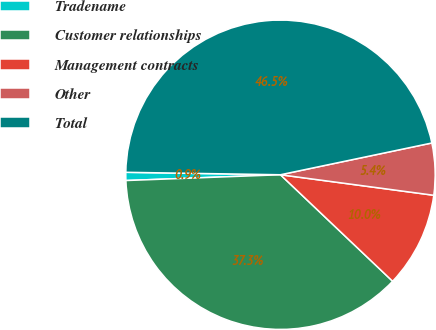Convert chart. <chart><loc_0><loc_0><loc_500><loc_500><pie_chart><fcel>Tradename<fcel>Customer relationships<fcel>Management contracts<fcel>Other<fcel>Total<nl><fcel>0.85%<fcel>37.31%<fcel>9.97%<fcel>5.41%<fcel>46.45%<nl></chart> 